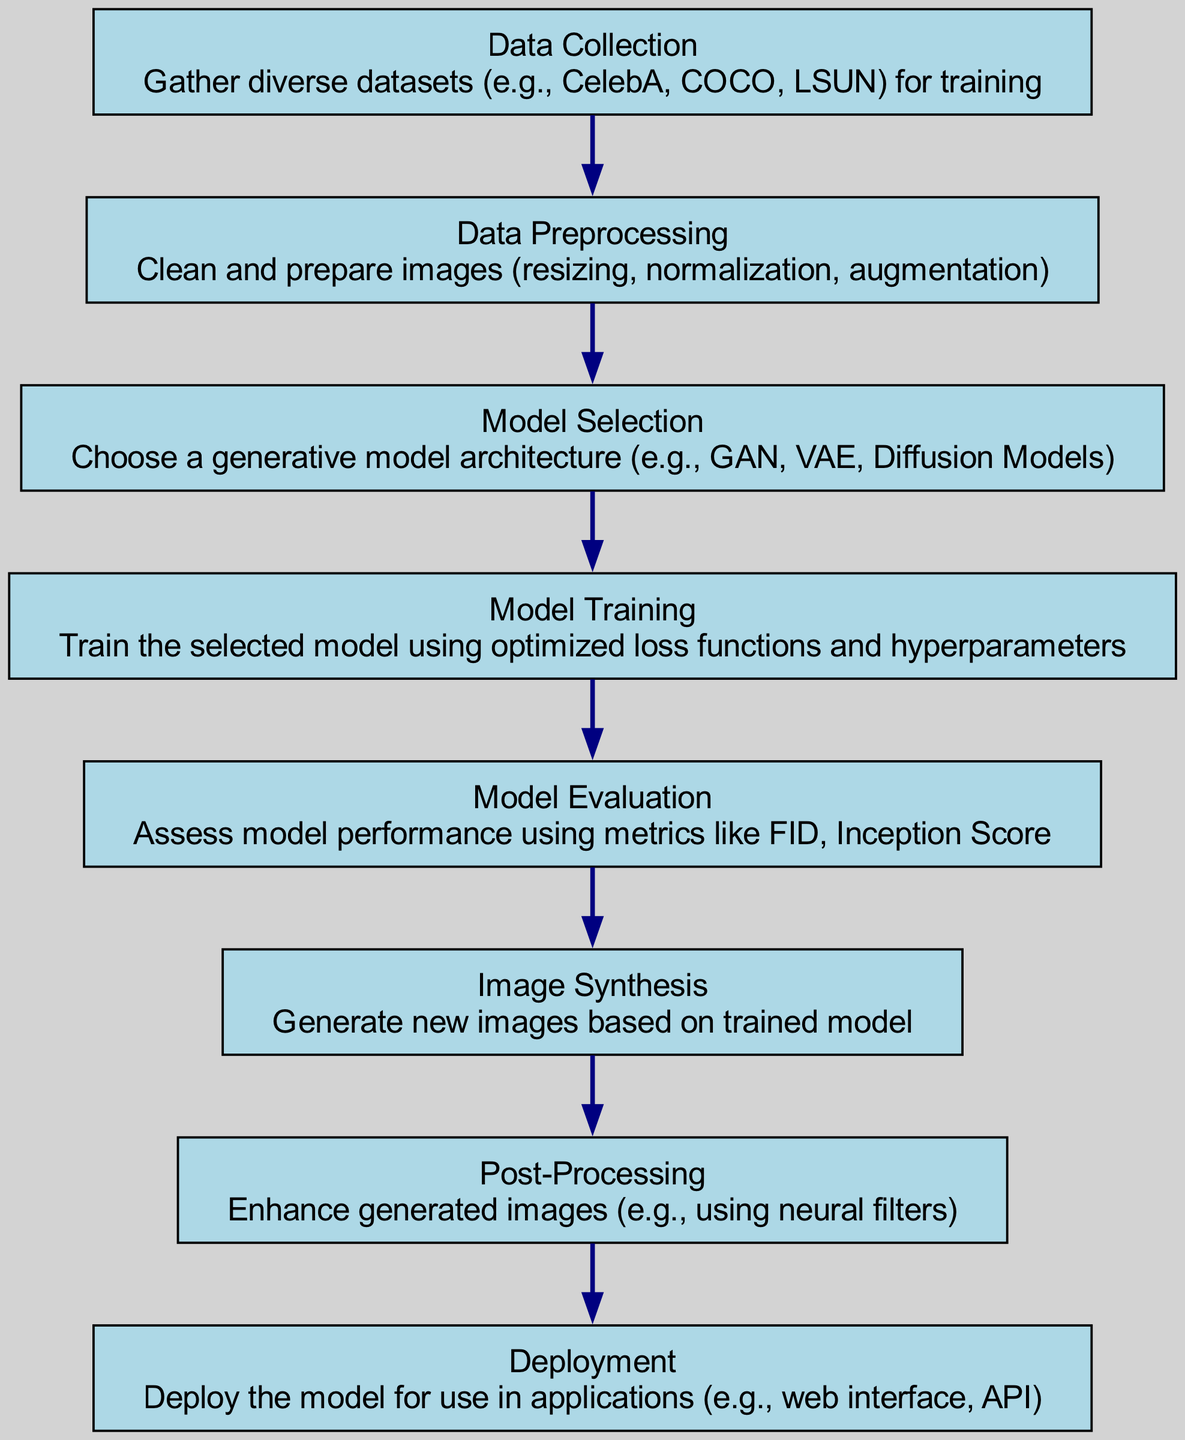What is the first step in the generative model workflow? The first step is "Data Collection," which involves gathering diverse datasets for training.
Answer: Data Collection How many nodes are there in the diagram? The diagram contains eight nodes, each representing a different stage in the generative model workflow.
Answer: Eight What is the last step before deploying the model? The last step before deployment is "Post-Processing," which enhances the generated images.
Answer: Post-Processing Which node follows "Model Training"? The node that follows "Model Training" is "Model Evaluation," where the model's performance is assessed.
Answer: Model Evaluation What is the relationship between "Image Synthesis" and "Model Evaluation"? "Image Synthesis" occurs after "Model Evaluation," as it relies on the trained and evaluated model.
Answer: Sequential What type of model architecture can be selected in the workflow? The model architectures that can be selected include GAN, VAE, and Diffusion Models as stated in "Model Selection."
Answer: GAN, VAE, Diffusion Models If the model performs poorly in "Model Evaluation," what should be revisited? If poor performance is observed, the "Model Training" process should be revisited to adjust parameters or techniques.
Answer: Model Training Which step directly produces new images? The step that directly produces new images is "Image Synthesis," where new images are generated based on the trained model.
Answer: Image Synthesis How does "Data Preprocessing" contribute to the workflow? "Data Preprocessing" contributes by ensuring the images are clean, properly sized, and augmented before training begins.
Answer: Prepares images 